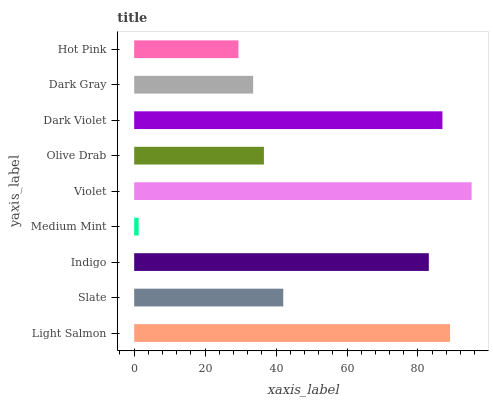Is Medium Mint the minimum?
Answer yes or no. Yes. Is Violet the maximum?
Answer yes or no. Yes. Is Slate the minimum?
Answer yes or no. No. Is Slate the maximum?
Answer yes or no. No. Is Light Salmon greater than Slate?
Answer yes or no. Yes. Is Slate less than Light Salmon?
Answer yes or no. Yes. Is Slate greater than Light Salmon?
Answer yes or no. No. Is Light Salmon less than Slate?
Answer yes or no. No. Is Slate the high median?
Answer yes or no. Yes. Is Slate the low median?
Answer yes or no. Yes. Is Medium Mint the high median?
Answer yes or no. No. Is Light Salmon the low median?
Answer yes or no. No. 